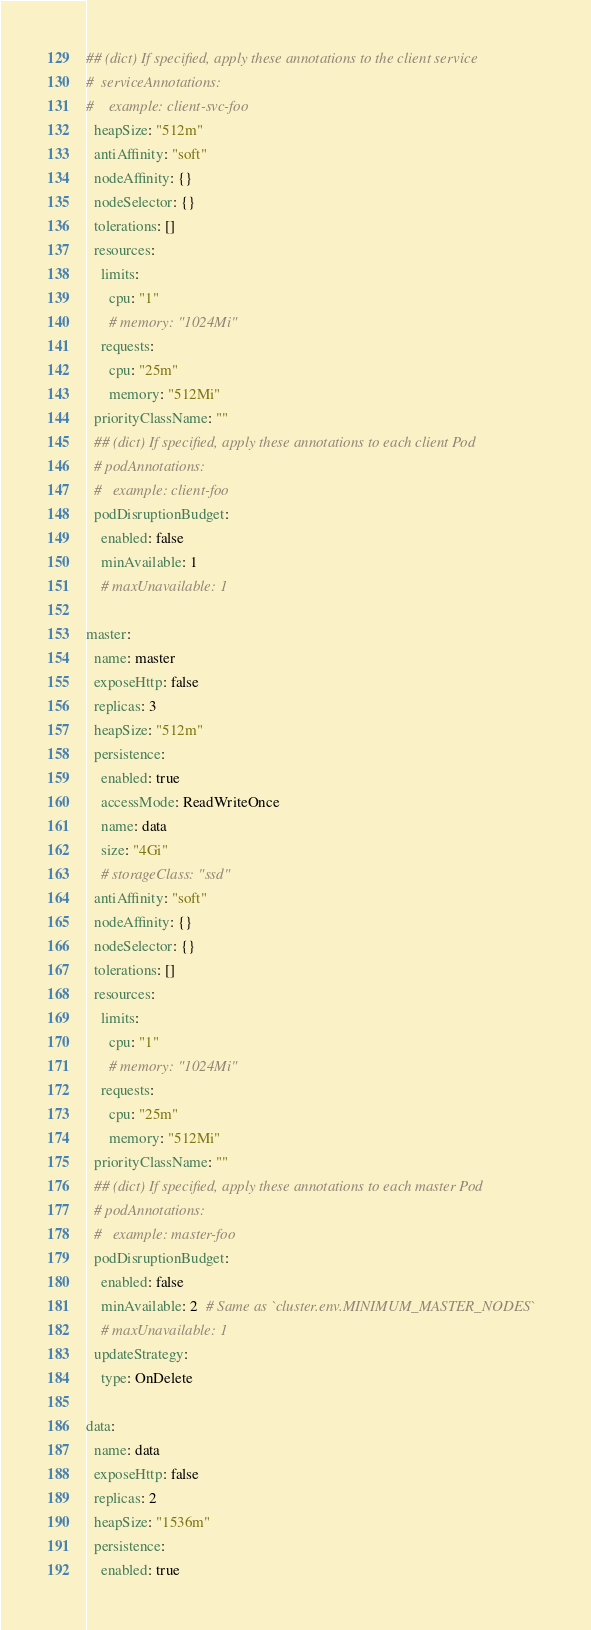<code> <loc_0><loc_0><loc_500><loc_500><_YAML_>## (dict) If specified, apply these annotations to the client service
#  serviceAnnotations:
#    example: client-svc-foo
  heapSize: "512m"
  antiAffinity: "soft"
  nodeAffinity: {}
  nodeSelector: {}
  tolerations: []
  resources:
    limits:
      cpu: "1"
      # memory: "1024Mi"
    requests:
      cpu: "25m"
      memory: "512Mi"
  priorityClassName: ""
  ## (dict) If specified, apply these annotations to each client Pod
  # podAnnotations:
  #   example: client-foo
  podDisruptionBudget:
    enabled: false
    minAvailable: 1
    # maxUnavailable: 1

master:
  name: master
  exposeHttp: false
  replicas: 3
  heapSize: "512m"
  persistence:
    enabled: true
    accessMode: ReadWriteOnce
    name: data
    size: "4Gi"
    # storageClass: "ssd"
  antiAffinity: "soft"
  nodeAffinity: {}
  nodeSelector: {}
  tolerations: []
  resources:
    limits:
      cpu: "1"
      # memory: "1024Mi"
    requests:
      cpu: "25m"
      memory: "512Mi"
  priorityClassName: ""
  ## (dict) If specified, apply these annotations to each master Pod
  # podAnnotations:
  #   example: master-foo
  podDisruptionBudget:
    enabled: false
    minAvailable: 2  # Same as `cluster.env.MINIMUM_MASTER_NODES`
    # maxUnavailable: 1
  updateStrategy:
    type: OnDelete

data:
  name: data
  exposeHttp: false
  replicas: 2
  heapSize: "1536m"
  persistence:
    enabled: true</code> 